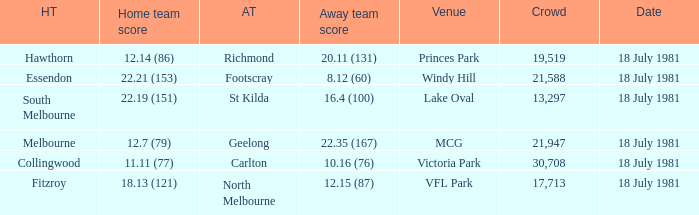On what date was the Essendon home match? 18 July 1981. 